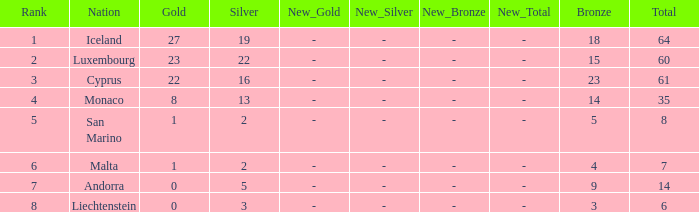How many bronzes for nations with over 22 golds and ranked under 2? 18.0. 